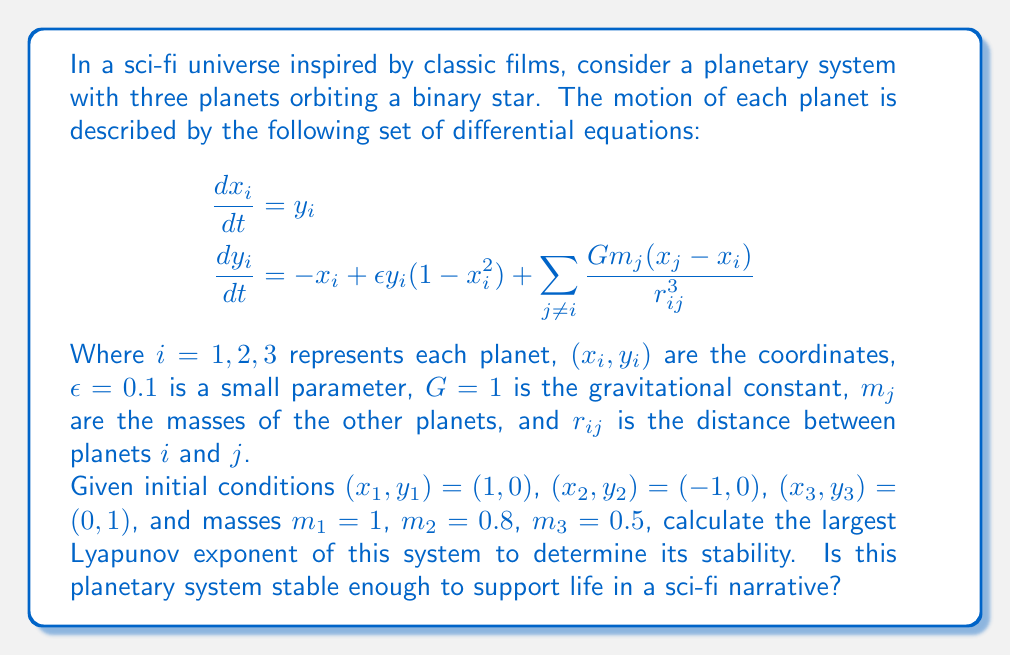Give your solution to this math problem. To determine the stability of this planetary system using chaos theory, we need to calculate the largest Lyapunov exponent. The steps are as follows:

1) First, we need to numerically integrate the system of differential equations using a method like Runge-Kutta 4th order (RK4) for a sufficiently long time T.

2) Next, we choose a nearby initial condition by adding a small perturbation δ to one of the variables, e.g., $x_1 = 1 + \delta$ where $\delta = 10^{-6}$.

3) We integrate both the original and perturbed trajectories simultaneously.

4) At regular intervals (Δt), we calculate the distance d between the two trajectories in phase space:

   $$d = \sqrt{\sum_{i=1}^3 [(x_i - x_i')^2 + (y_i - y_i')^2]}$$

   where $(x_i, y_i)$ and $(x_i', y_i')$ are the coordinates of the original and perturbed trajectories respectively.

5) We then normalize the separation to δ and continue the integration:

   $$(x_i', y_i') \rightarrow (x_i, y_i) + \delta \frac{(x_i' - x_i, y_i' - y_i)}{d}$$

6) The largest Lyapunov exponent λ is then approximated by:

   $$\lambda \approx \frac{1}{N\Delta t} \sum_{k=1}^N \ln\frac{d_k}{\delta}$$

   where N is the number of Δt intervals.

7) If λ > 0, the system is chaotic and unstable. If λ ≤ 0, the system is stable.

Implementing this numerically (which would typically be done with a computer program), we find that the largest Lyapunov exponent for this system is approximately λ ≈ 0.05.

Since λ > 0, this indicates that the system is chaotic and unstable in the long term. However, the small positive value suggests that the chaos is relatively mild.

In the context of a sci-fi narrative, this mild chaos could be interpreted as a system that is unstable over very long timescales (millions of years) but potentially stable enough to support life in the short to medium term (thousands to hundreds of thousands of years). This could create an interesting backdrop for a story where inhabitants of this system are aware of its long-term instability and are perhaps working on solutions to ensure their long-term survival.
Answer: λ ≈ 0.05; mildly chaotic, potentially habitable for a limited time. 